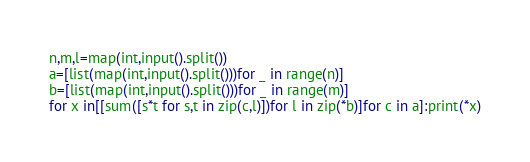Convert code to text. <code><loc_0><loc_0><loc_500><loc_500><_Python_>n,m,l=map(int,input().split())
a=[list(map(int,input().split()))for _ in range(n)]
b=[list(map(int,input().split()))for _ in range(m)]
for x in[[sum([s*t for s,t in zip(c,l)])for l in zip(*b)]for c in a]:print(*x)
</code> 